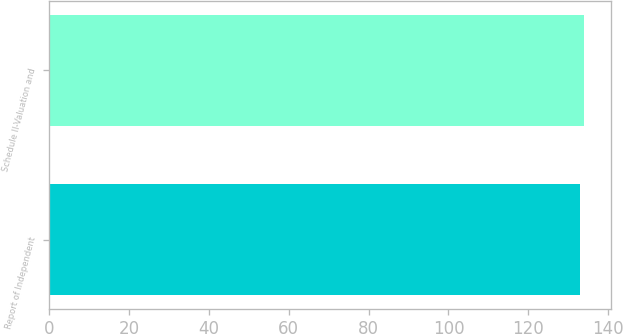<chart> <loc_0><loc_0><loc_500><loc_500><bar_chart><fcel>Report of Independent<fcel>Schedule II-Valuation and<nl><fcel>133<fcel>134<nl></chart> 